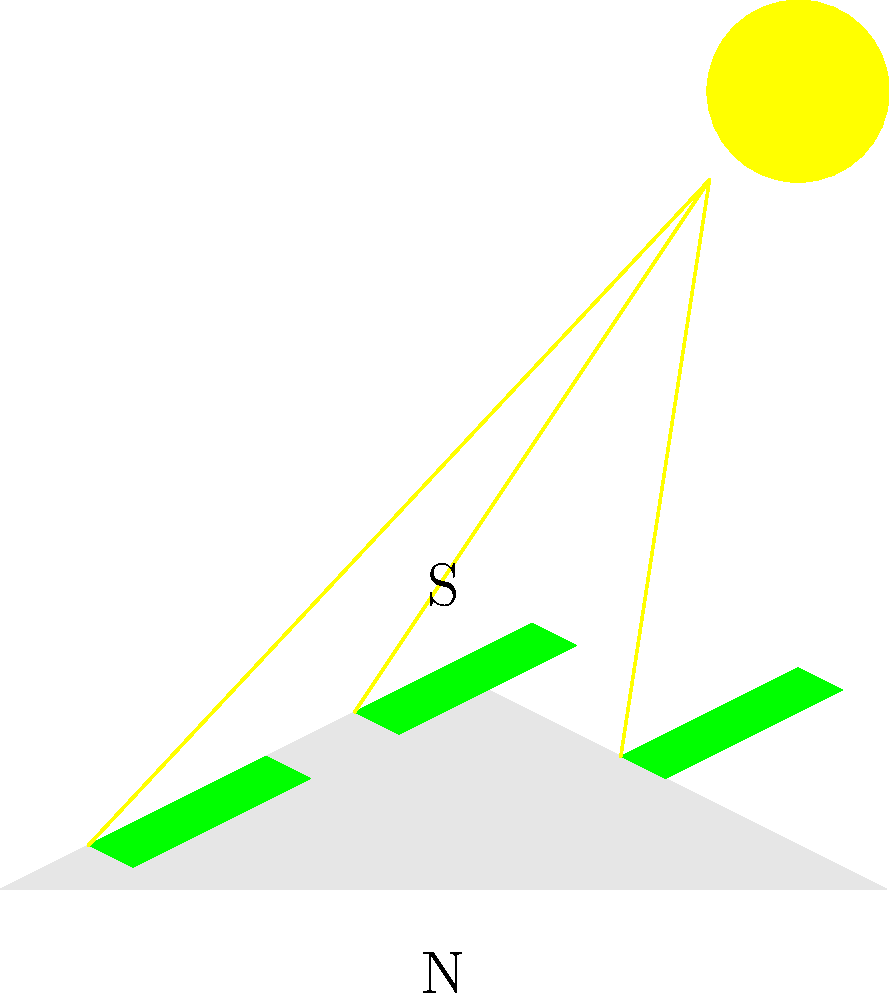Based on the satellite imagery of a roof with existing solar panels, which direction should additional panels be oriented to maximize energy production while minimizing environmental impact? To determine the optimal orientation for additional solar panels, we need to consider several factors:

1. Existing panel orientation: The current panels are facing south (top of the image), which is generally ideal for maximum sun exposure in the Northern Hemisphere.

2. Sun position: The sun is depicted in the upper right corner, indicating a southern exposure.

3. Roof slope: The roof has a symmetrical pitch, with the ridge running east-west.

4. Environmental impact: As a nationalist environmentalist, we want to maximize energy production while minimizing the impact on local ecosystems and aesthetics.

5. Energy production: South-facing panels typically produce the most energy in the Northern Hemisphere due to maximum sun exposure throughout the day.

6. Available space: There is still room on the south-facing slope for additional panels.

Considering these factors:

1. Placing additional panels on the south-facing slope would maximize energy production.
2. This orientation aligns with existing panels, maintaining a uniform appearance.
3. Utilizing the existing roof structure minimizes additional environmental impact.
4. South-facing panels contribute to national energy independence goals.

Therefore, orienting additional panels to face south (top of the image) would be the optimal choice for maximizing energy production while aligning with environmentalist and nationalist values.
Answer: South-facing 